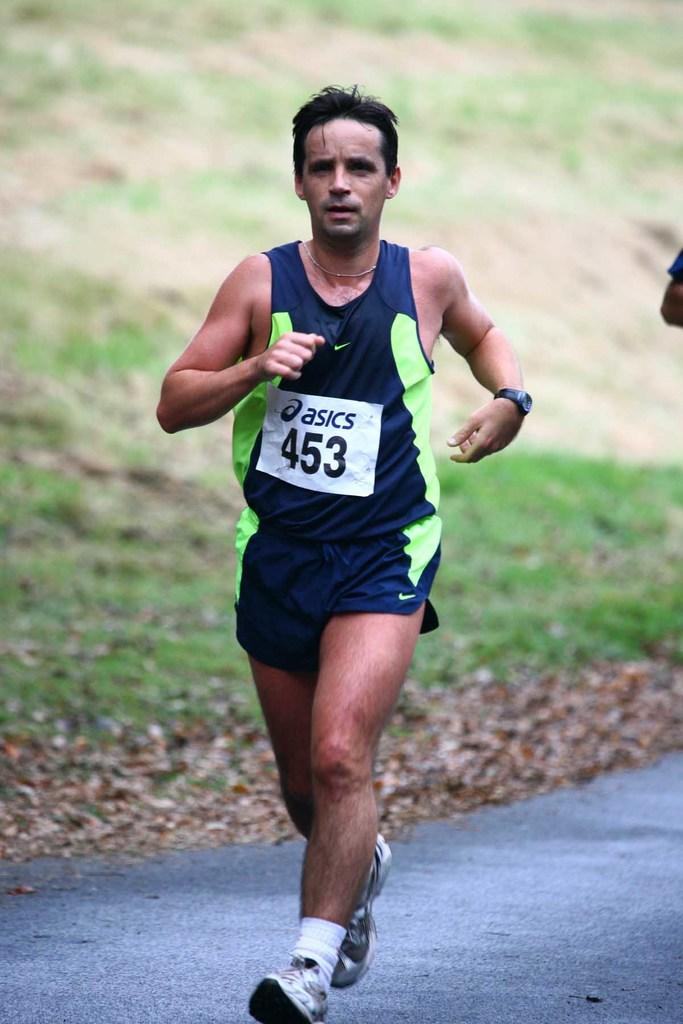<image>
Write a terse but informative summary of the picture. Man wearing a number 453 on his shirt. 